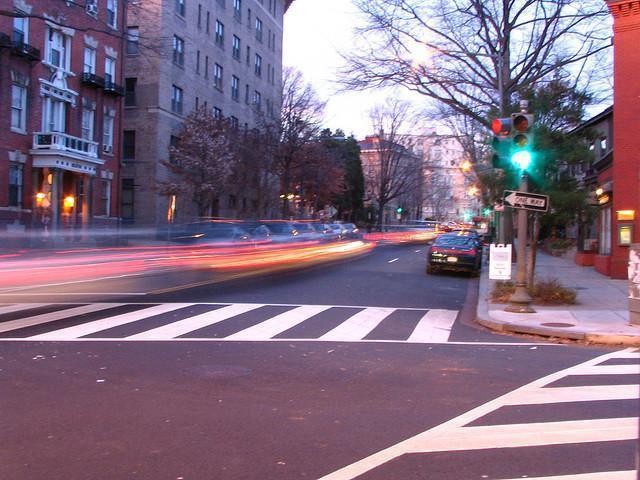How many people are standing and posing for the photo?
Give a very brief answer. 0. 